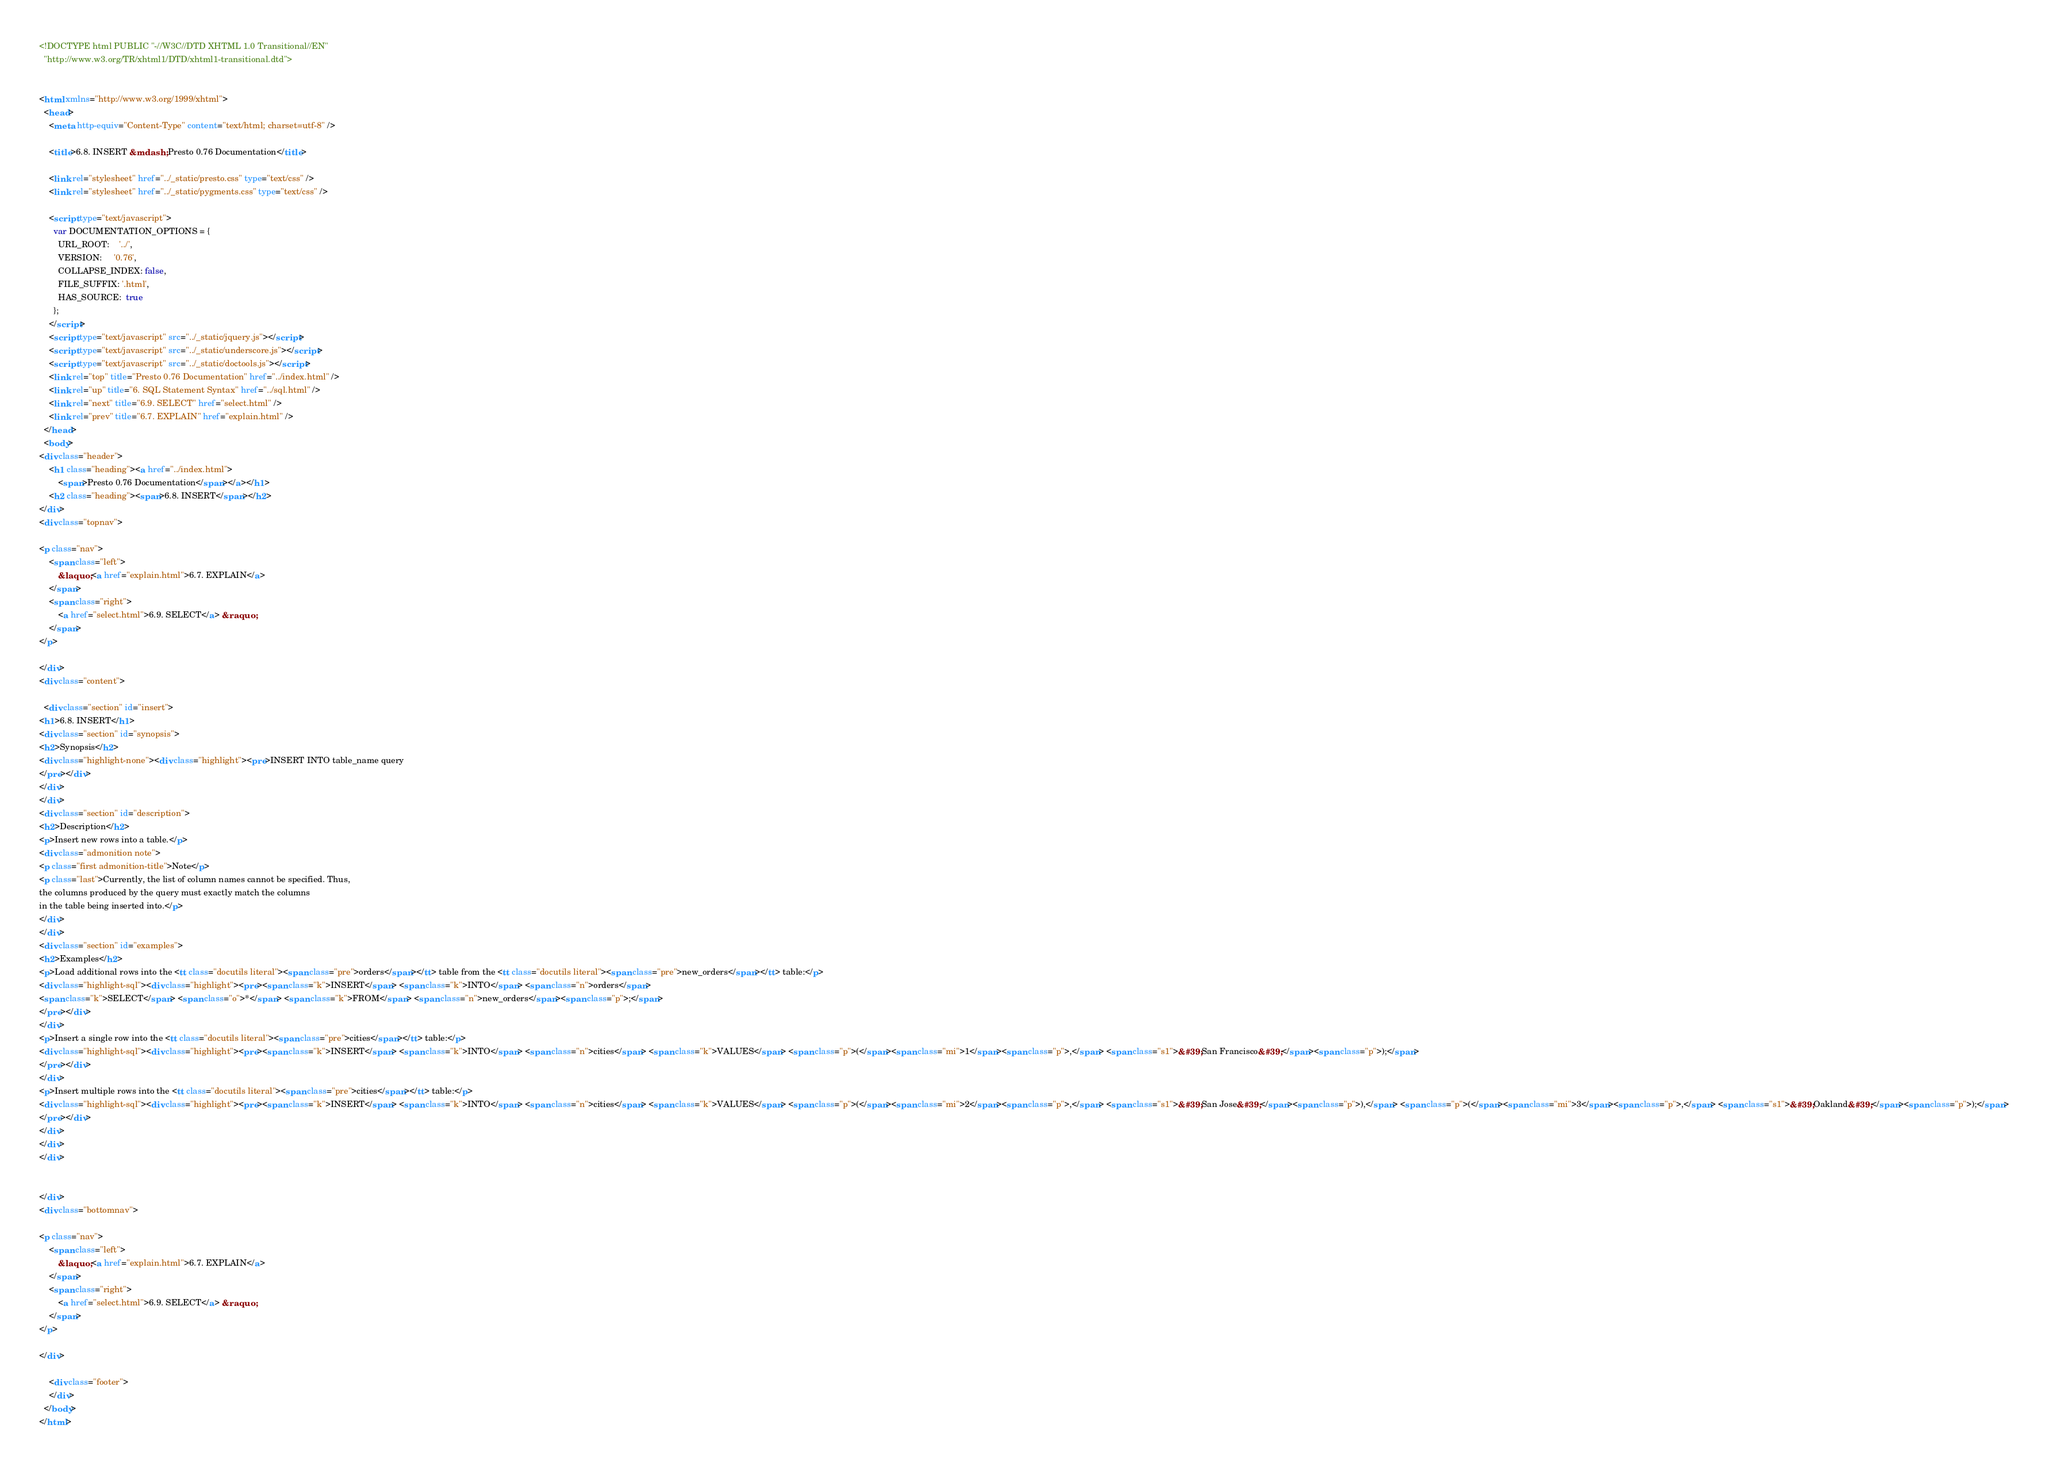<code> <loc_0><loc_0><loc_500><loc_500><_HTML_>
<!DOCTYPE html PUBLIC "-//W3C//DTD XHTML 1.0 Transitional//EN"
  "http://www.w3.org/TR/xhtml1/DTD/xhtml1-transitional.dtd">


<html xmlns="http://www.w3.org/1999/xhtml">
  <head>
    <meta http-equiv="Content-Type" content="text/html; charset=utf-8" />
    
    <title>6.8. INSERT &mdash; Presto 0.76 Documentation</title>
    
    <link rel="stylesheet" href="../_static/presto.css" type="text/css" />
    <link rel="stylesheet" href="../_static/pygments.css" type="text/css" />
    
    <script type="text/javascript">
      var DOCUMENTATION_OPTIONS = {
        URL_ROOT:    '../',
        VERSION:     '0.76',
        COLLAPSE_INDEX: false,
        FILE_SUFFIX: '.html',
        HAS_SOURCE:  true
      };
    </script>
    <script type="text/javascript" src="../_static/jquery.js"></script>
    <script type="text/javascript" src="../_static/underscore.js"></script>
    <script type="text/javascript" src="../_static/doctools.js"></script>
    <link rel="top" title="Presto 0.76 Documentation" href="../index.html" />
    <link rel="up" title="6. SQL Statement Syntax" href="../sql.html" />
    <link rel="next" title="6.9. SELECT" href="select.html" />
    <link rel="prev" title="6.7. EXPLAIN" href="explain.html" /> 
  </head>
  <body>
<div class="header">
    <h1 class="heading"><a href="../index.html">
        <span>Presto 0.76 Documentation</span></a></h1>
    <h2 class="heading"><span>6.8. INSERT</span></h2>
</div>
<div class="topnav">
    
<p class="nav">
    <span class="left">
        &laquo; <a href="explain.html">6.7. EXPLAIN</a>
    </span>
    <span class="right">
        <a href="select.html">6.9. SELECT</a> &raquo;
    </span>
</p>

</div>
<div class="content">
    
  <div class="section" id="insert">
<h1>6.8. INSERT</h1>
<div class="section" id="synopsis">
<h2>Synopsis</h2>
<div class="highlight-none"><div class="highlight"><pre>INSERT INTO table_name query
</pre></div>
</div>
</div>
<div class="section" id="description">
<h2>Description</h2>
<p>Insert new rows into a table.</p>
<div class="admonition note">
<p class="first admonition-title">Note</p>
<p class="last">Currently, the list of column names cannot be specified. Thus,
the columns produced by the query must exactly match the columns
in the table being inserted into.</p>
</div>
</div>
<div class="section" id="examples">
<h2>Examples</h2>
<p>Load additional rows into the <tt class="docutils literal"><span class="pre">orders</span></tt> table from the <tt class="docutils literal"><span class="pre">new_orders</span></tt> table:</p>
<div class="highlight-sql"><div class="highlight"><pre><span class="k">INSERT</span> <span class="k">INTO</span> <span class="n">orders</span>
<span class="k">SELECT</span> <span class="o">*</span> <span class="k">FROM</span> <span class="n">new_orders</span><span class="p">;</span>
</pre></div>
</div>
<p>Insert a single row into the <tt class="docutils literal"><span class="pre">cities</span></tt> table:</p>
<div class="highlight-sql"><div class="highlight"><pre><span class="k">INSERT</span> <span class="k">INTO</span> <span class="n">cities</span> <span class="k">VALUES</span> <span class="p">(</span><span class="mi">1</span><span class="p">,</span> <span class="s1">&#39;San Francisco&#39;</span><span class="p">);</span>
</pre></div>
</div>
<p>Insert multiple rows into the <tt class="docutils literal"><span class="pre">cities</span></tt> table:</p>
<div class="highlight-sql"><div class="highlight"><pre><span class="k">INSERT</span> <span class="k">INTO</span> <span class="n">cities</span> <span class="k">VALUES</span> <span class="p">(</span><span class="mi">2</span><span class="p">,</span> <span class="s1">&#39;San Jose&#39;</span><span class="p">),</span> <span class="p">(</span><span class="mi">3</span><span class="p">,</span> <span class="s1">&#39;Oakland&#39;</span><span class="p">);</span>
</pre></div>
</div>
</div>
</div>


</div>
<div class="bottomnav">
    
<p class="nav">
    <span class="left">
        &laquo; <a href="explain.html">6.7. EXPLAIN</a>
    </span>
    <span class="right">
        <a href="select.html">6.9. SELECT</a> &raquo;
    </span>
</p>

</div>

    <div class="footer">
    </div>
  </body>
</html></code> 